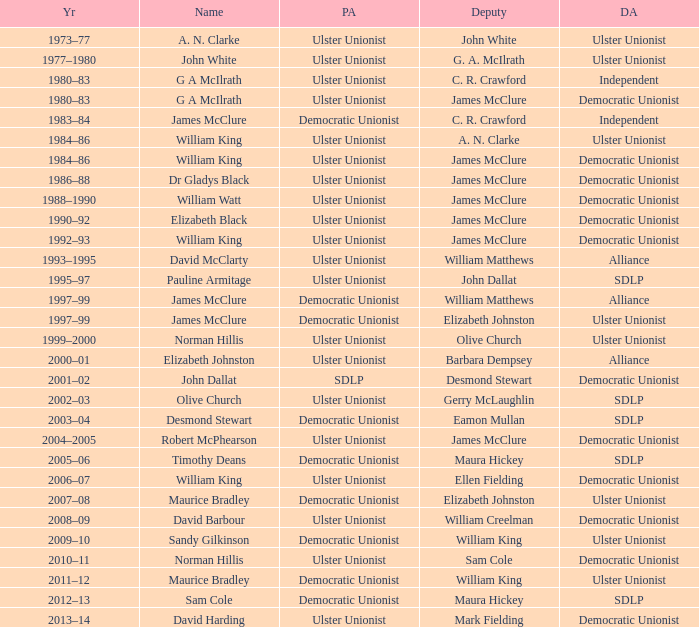What is the name of the Deputy when the Name was elizabeth black? James McClure. 